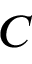Convert formula to latex. <formula><loc_0><loc_0><loc_500><loc_500>C</formula> 